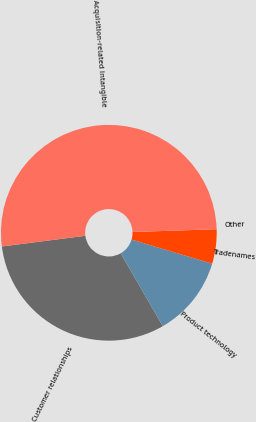Convert chart. <chart><loc_0><loc_0><loc_500><loc_500><pie_chart><fcel>Customer relationships<fcel>Product technology<fcel>Tradenames<fcel>Other<fcel>Acquisition-related Intangible<nl><fcel>31.31%<fcel>12.03%<fcel>5.15%<fcel>0.0%<fcel>51.5%<nl></chart> 